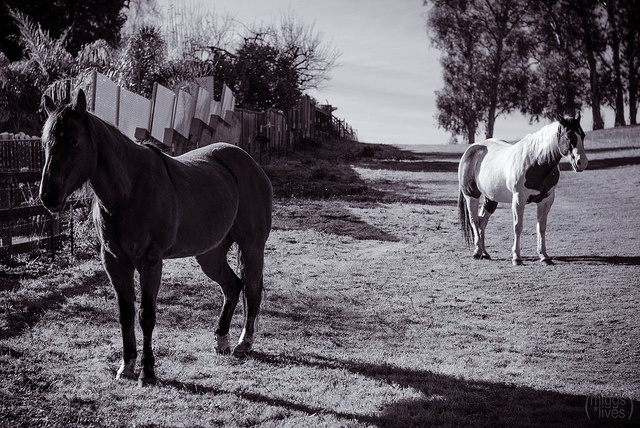Describe the objects in this image and their specific colors. I can see horse in black, gray, and darkgray tones and horse in black, lightgray, gray, and darkgray tones in this image. 